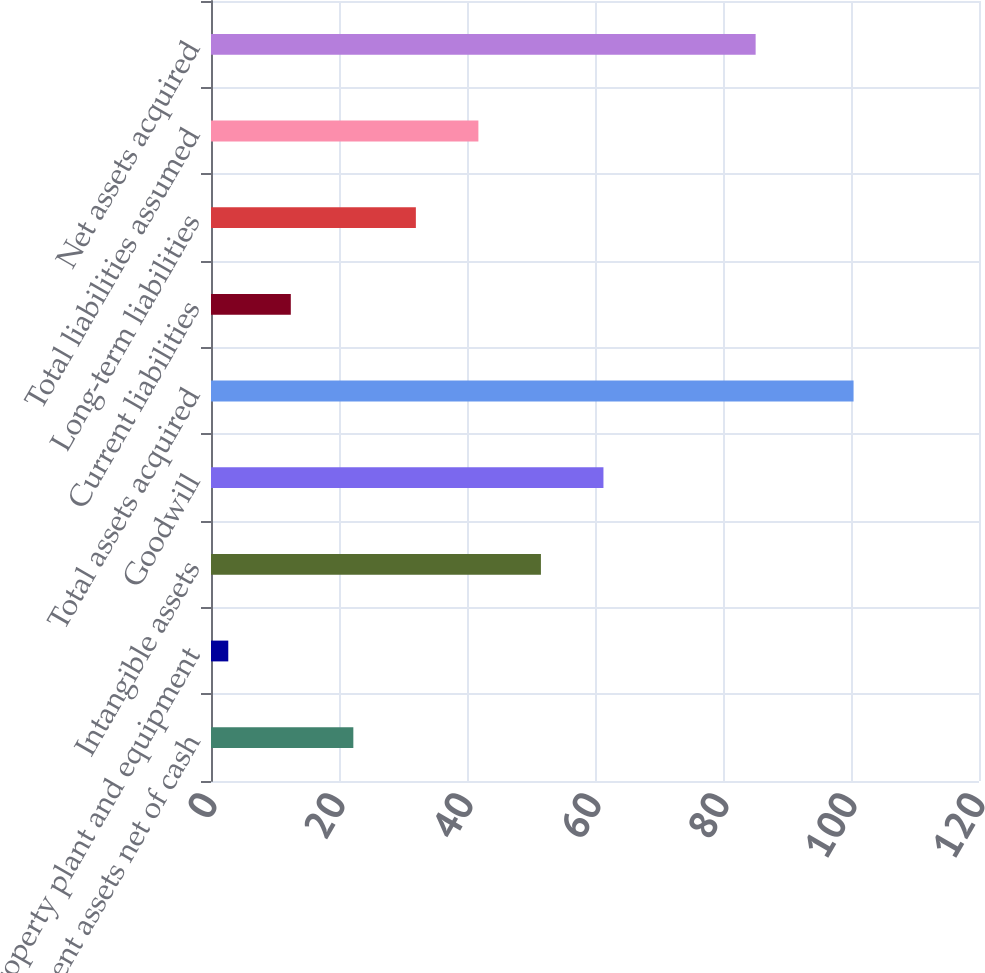Convert chart. <chart><loc_0><loc_0><loc_500><loc_500><bar_chart><fcel>Current assets net of cash<fcel>Property plant and equipment<fcel>Intangible assets<fcel>Goodwill<fcel>Total assets acquired<fcel>Current liabilities<fcel>Long-term liabilities<fcel>Total liabilities assumed<fcel>Net assets acquired<nl><fcel>22.24<fcel>2.7<fcel>51.55<fcel>61.32<fcel>100.4<fcel>12.47<fcel>32.01<fcel>41.78<fcel>85.1<nl></chart> 